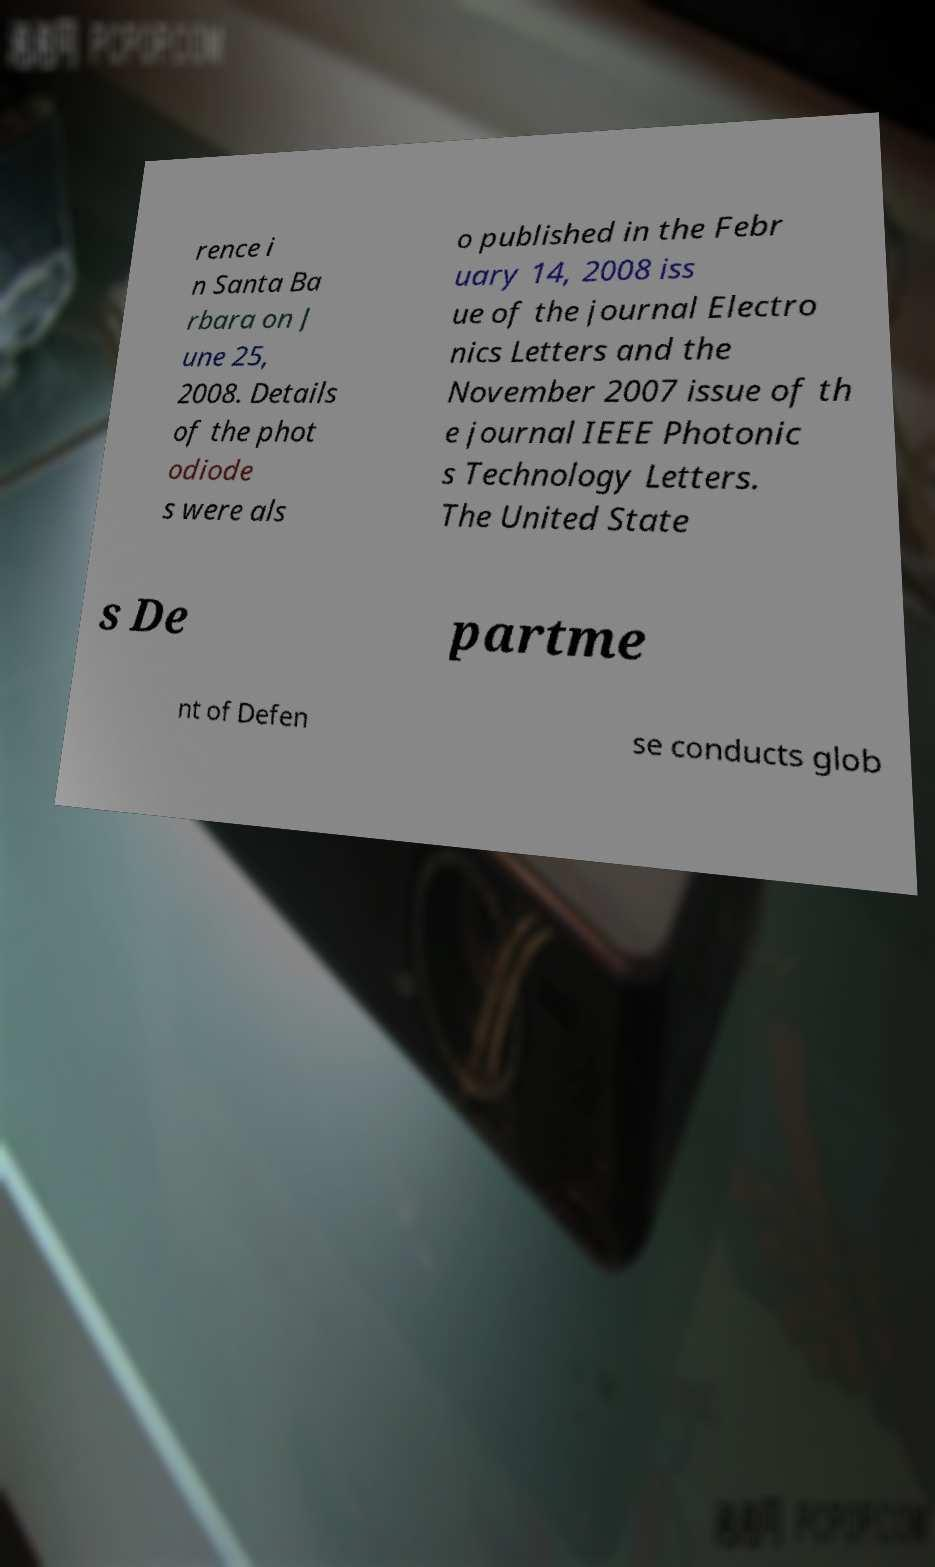Could you assist in decoding the text presented in this image and type it out clearly? rence i n Santa Ba rbara on J une 25, 2008. Details of the phot odiode s were als o published in the Febr uary 14, 2008 iss ue of the journal Electro nics Letters and the November 2007 issue of th e journal IEEE Photonic s Technology Letters. The United State s De partme nt of Defen se conducts glob 